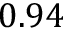Convert formula to latex. <formula><loc_0><loc_0><loc_500><loc_500>0 . 9 4</formula> 